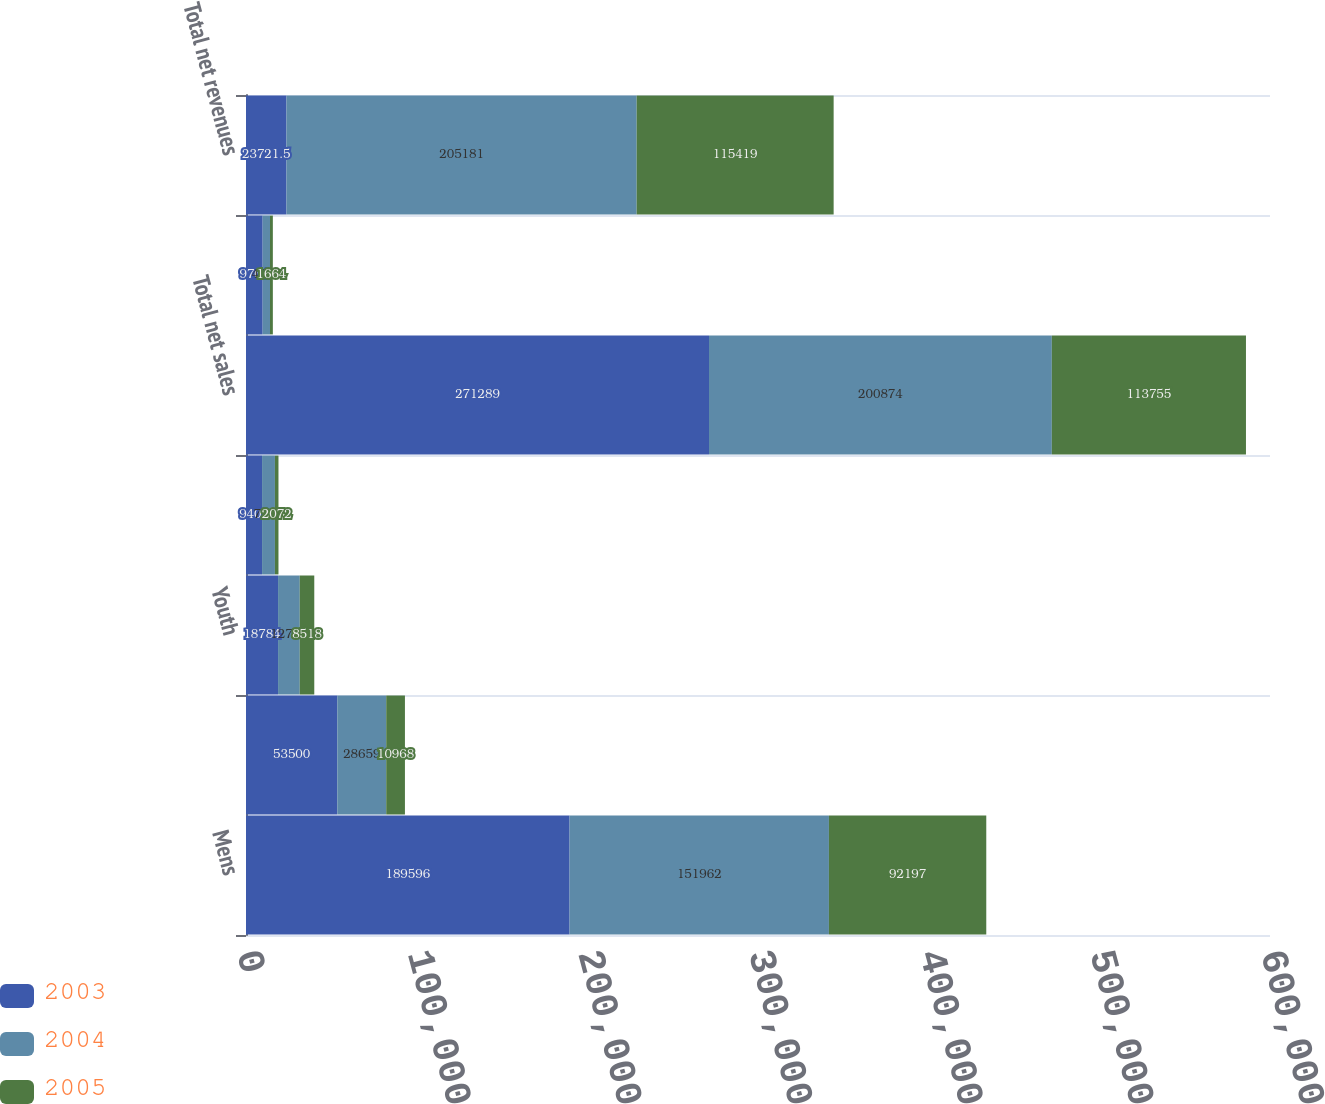Convert chart. <chart><loc_0><loc_0><loc_500><loc_500><stacked_bar_chart><ecel><fcel>Mens<fcel>Womens<fcel>Youth<fcel>Accessories<fcel>Total net sales<fcel>License revenues<fcel>Total net revenues<nl><fcel>2003<fcel>189596<fcel>53500<fcel>18784<fcel>9409<fcel>271289<fcel>9764<fcel>23721.5<nl><fcel>2004<fcel>151962<fcel>28659<fcel>12705<fcel>7548<fcel>200874<fcel>4307<fcel>205181<nl><fcel>2005<fcel>92197<fcel>10968<fcel>8518<fcel>2072<fcel>113755<fcel>1664<fcel>115419<nl></chart> 